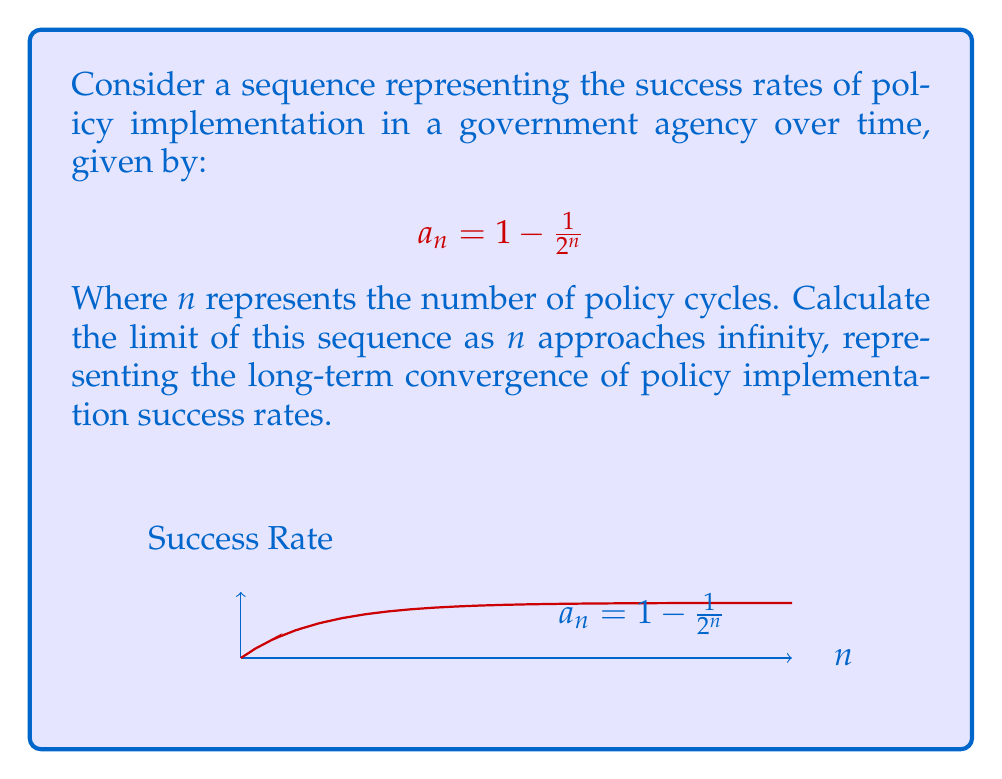Can you answer this question? To find the limit of the sequence $a_n = 1 - \frac{1}{2^n}$ as $n$ approaches infinity, we can follow these steps:

1) First, let's consider what happens to $\frac{1}{2^n}$ as $n$ gets very large:
   
   As $n \to \infty$, $2^n$ becomes extremely large.
   
   Therefore, $\frac{1}{2^n}$ becomes extremely small, approaching 0.

2) Now, let's look at the full expression:
   
   $\lim_{n \to \infty} a_n = \lim_{n \to \infty} (1 - \frac{1}{2^n})$

3) We can separate this limit:
   
   $\lim_{n \to \infty} (1 - \frac{1}{2^n}) = \lim_{n \to \infty} 1 - \lim_{n \to \infty} \frac{1}{2^n}$

4) We know that:
   
   $\lim_{n \to \infty} 1 = 1$
   
   $\lim_{n \to \infty} \frac{1}{2^n} = 0$

5) Therefore:
   
   $\lim_{n \to \infty} a_n = 1 - 0 = 1$

This means that as the number of policy cycles increases indefinitely, the success rate of policy implementation converges to 1, or 100%.
Answer: $\lim_{n \to \infty} a_n = 1$ 